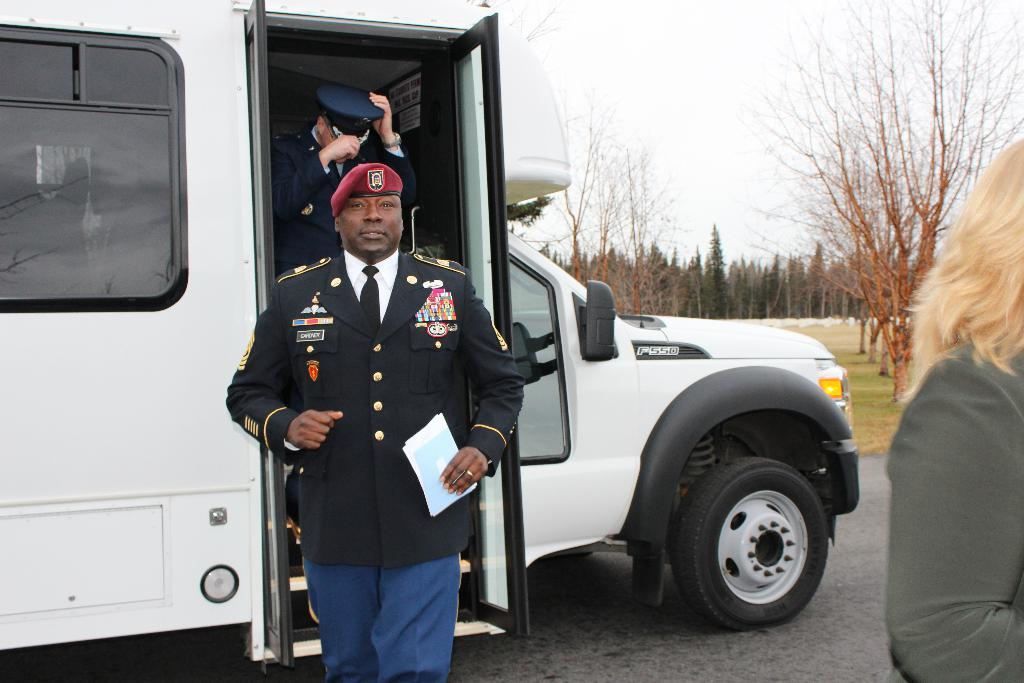What is on the road in the image? There is a vehicle on the road in the image. What type of natural environment can be seen in the image? There is grass and trees visible in the image. How many people are in the image? There are three people in the image. What is one of the people holding in his hand? A man is holding a paper in his hand. What is visible in the background of the image? The sky is visible in the background of the image. What disease is the person in the image suffering from? There is no indication in the image that any of the people are suffering from a disease. Can you tell me how many times the person in the image kicked the ball? There is no ball present in the image, so it is not possible to determine how many times the person kicked it. 